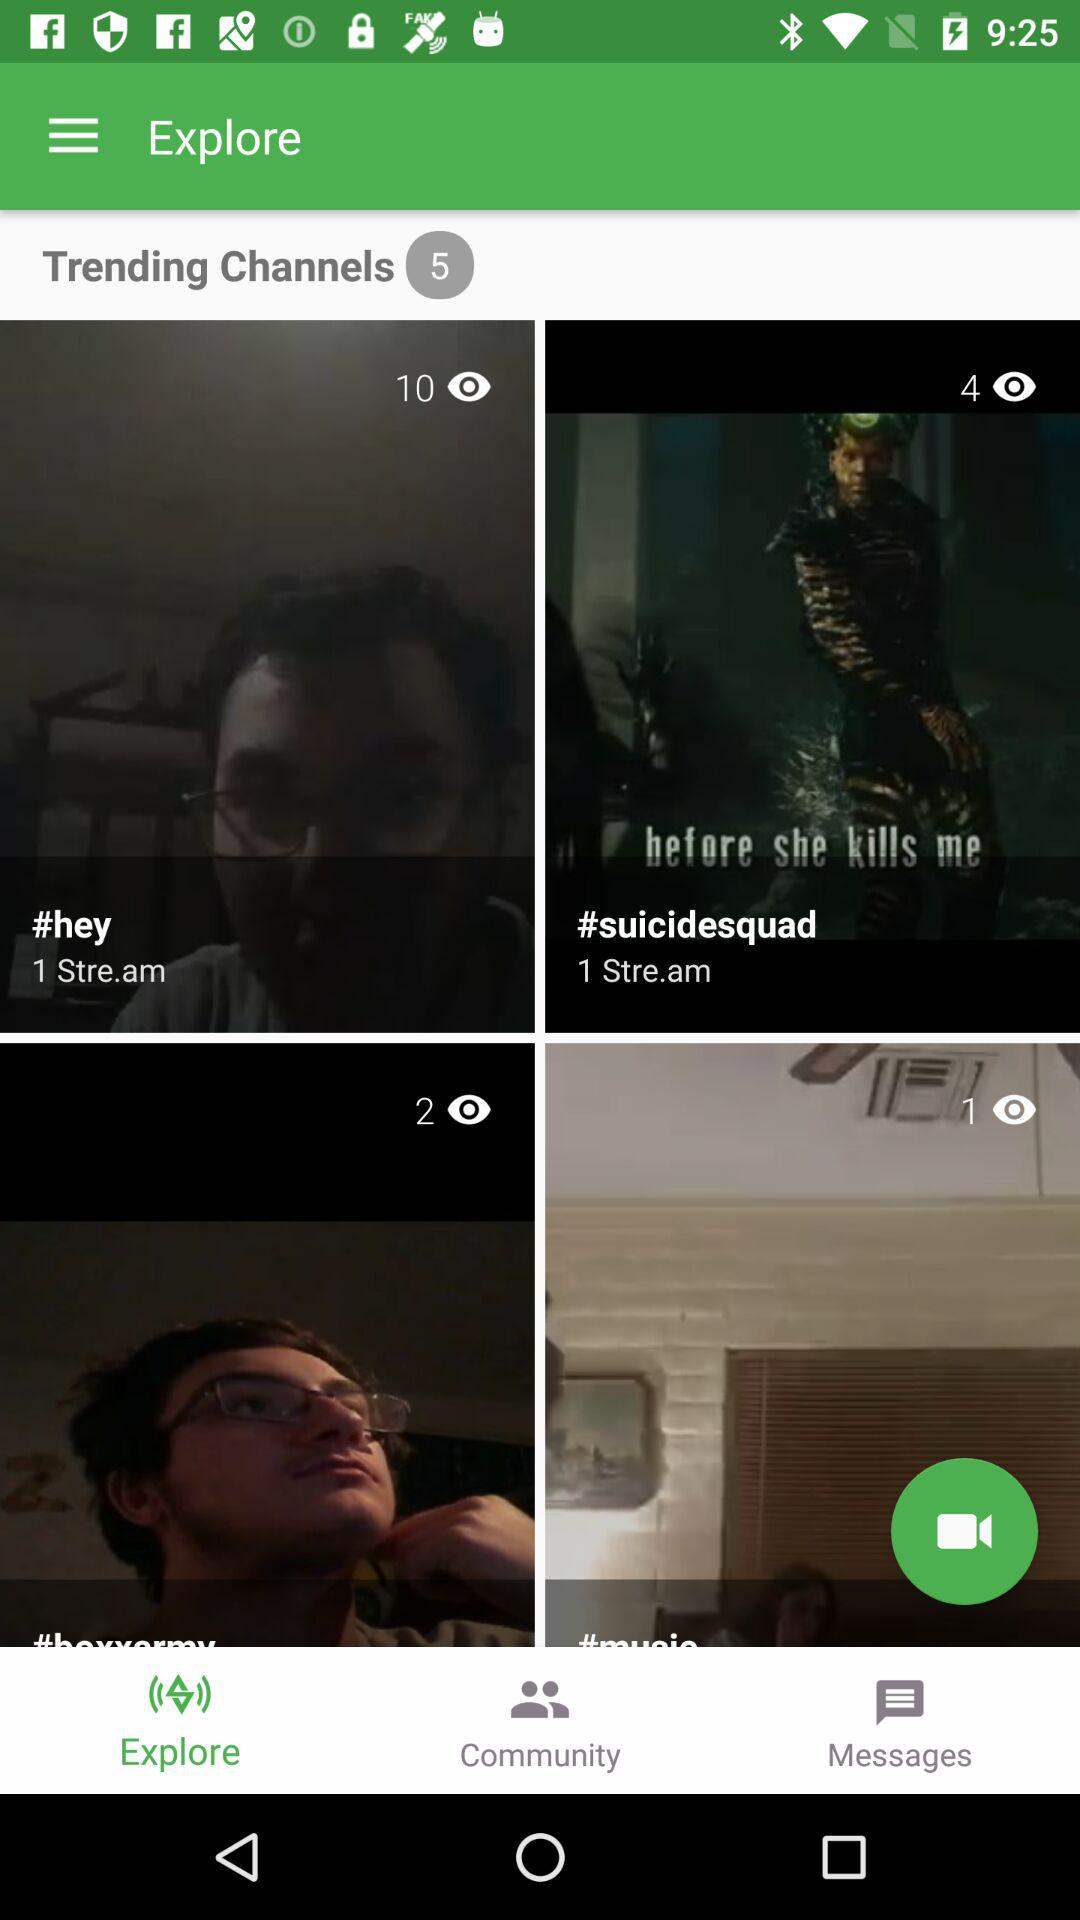How many viewers are watching the live stream of "#suicidesquad"? There are 4 viewers. 